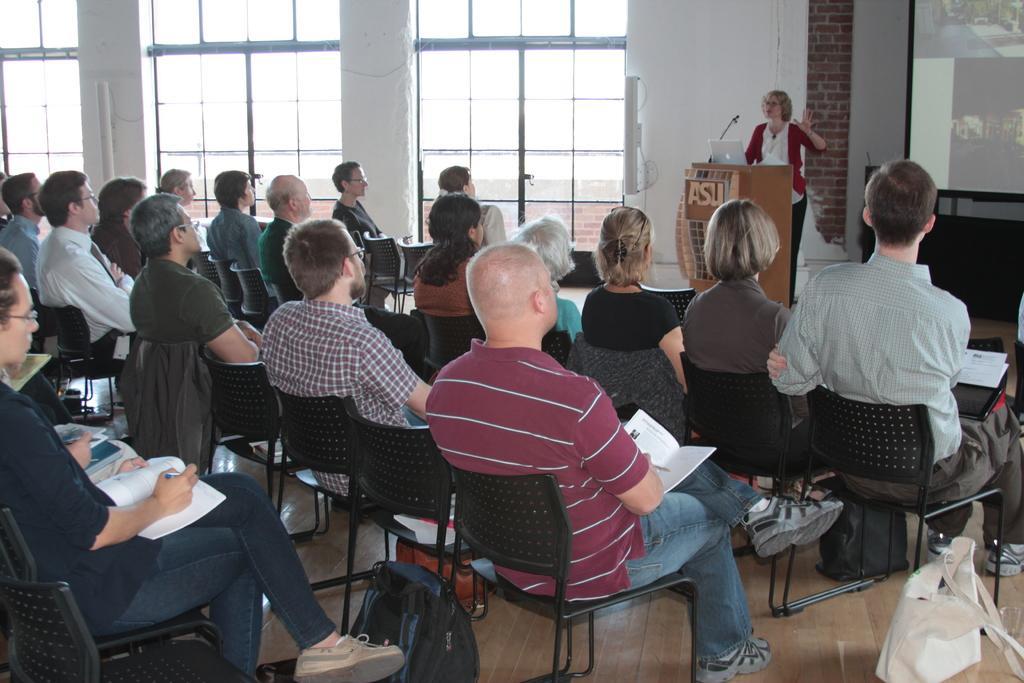Please provide a concise description of this image. This image is clicked in a meeting room. There are many people sitting in the chairs. To the right, there is a woman standing near the podium and talking. To the right, there is a projector screen. To the left in background there are windows and pillars. 